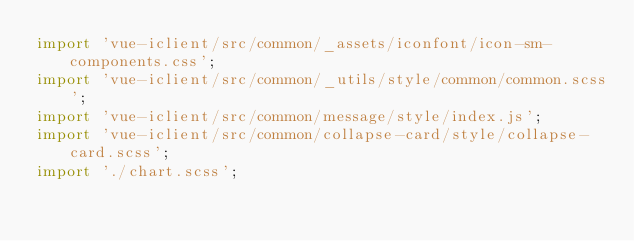<code> <loc_0><loc_0><loc_500><loc_500><_JavaScript_>import 'vue-iclient/src/common/_assets/iconfont/icon-sm-components.css';
import 'vue-iclient/src/common/_utils/style/common/common.scss';
import 'vue-iclient/src/common/message/style/index.js';
import 'vue-iclient/src/common/collapse-card/style/collapse-card.scss';
import './chart.scss';
</code> 